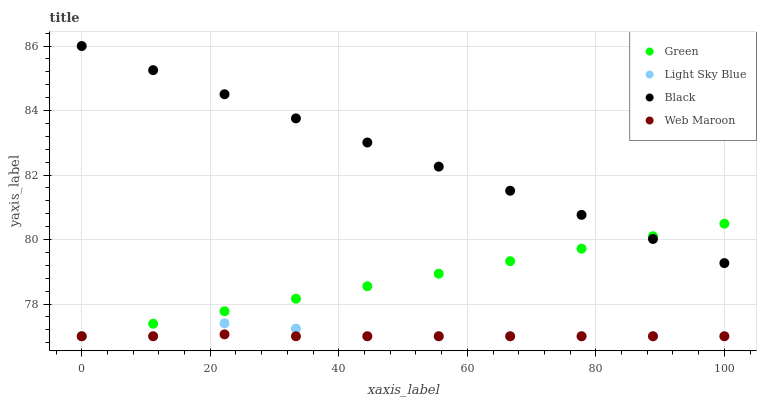Does Web Maroon have the minimum area under the curve?
Answer yes or no. Yes. Does Black have the maximum area under the curve?
Answer yes or no. Yes. Does Light Sky Blue have the minimum area under the curve?
Answer yes or no. No. Does Light Sky Blue have the maximum area under the curve?
Answer yes or no. No. Is Black the smoothest?
Answer yes or no. Yes. Is Light Sky Blue the roughest?
Answer yes or no. Yes. Is Green the smoothest?
Answer yes or no. No. Is Green the roughest?
Answer yes or no. No. Does Light Sky Blue have the lowest value?
Answer yes or no. Yes. Does Black have the highest value?
Answer yes or no. Yes. Does Light Sky Blue have the highest value?
Answer yes or no. No. Is Light Sky Blue less than Black?
Answer yes or no. Yes. Is Black greater than Light Sky Blue?
Answer yes or no. Yes. Does Web Maroon intersect Light Sky Blue?
Answer yes or no. Yes. Is Web Maroon less than Light Sky Blue?
Answer yes or no. No. Is Web Maroon greater than Light Sky Blue?
Answer yes or no. No. Does Light Sky Blue intersect Black?
Answer yes or no. No. 